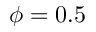<formula> <loc_0><loc_0><loc_500><loc_500>\phi = 0 . 5</formula> 